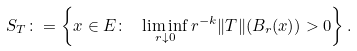Convert formula to latex. <formula><loc_0><loc_0><loc_500><loc_500>S _ { T } \colon = \left \{ x \in E \colon \ \liminf _ { r \downarrow 0 } r ^ { - k } \| T \| ( B _ { r } ( x ) ) > 0 \right \} .</formula> 